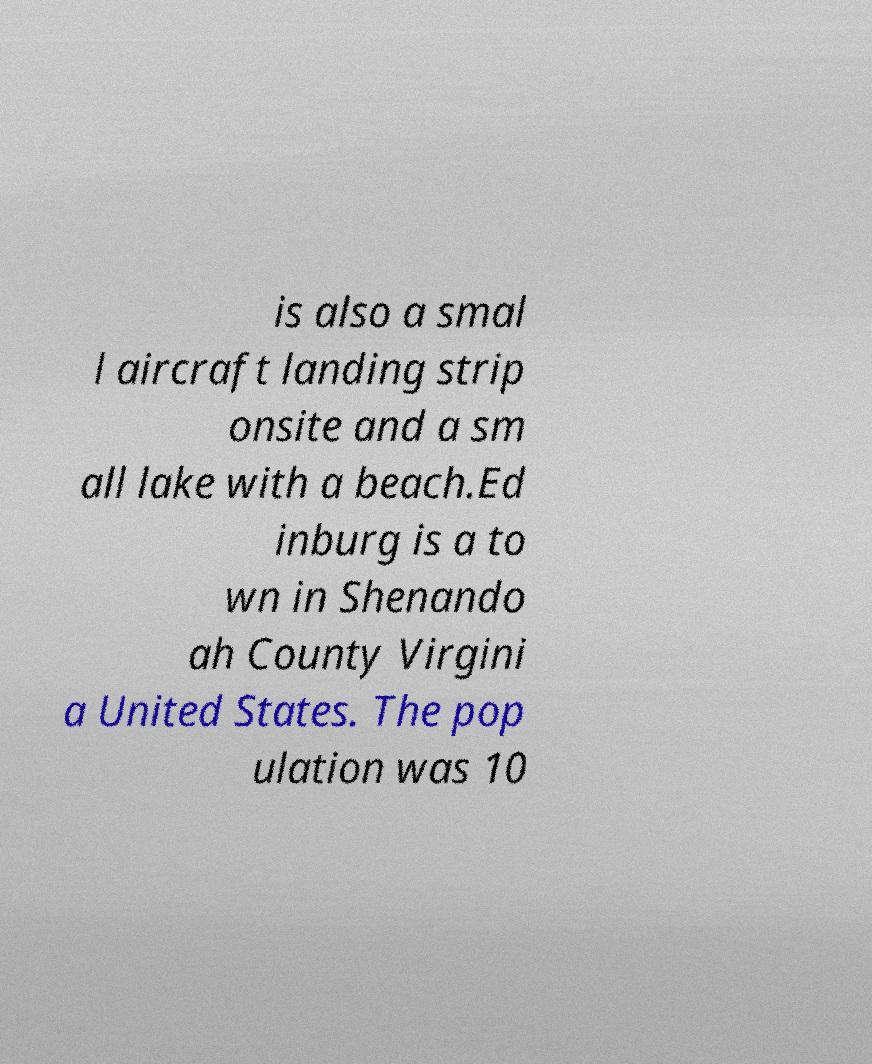Can you accurately transcribe the text from the provided image for me? is also a smal l aircraft landing strip onsite and a sm all lake with a beach.Ed inburg is a to wn in Shenando ah County Virgini a United States. The pop ulation was 10 